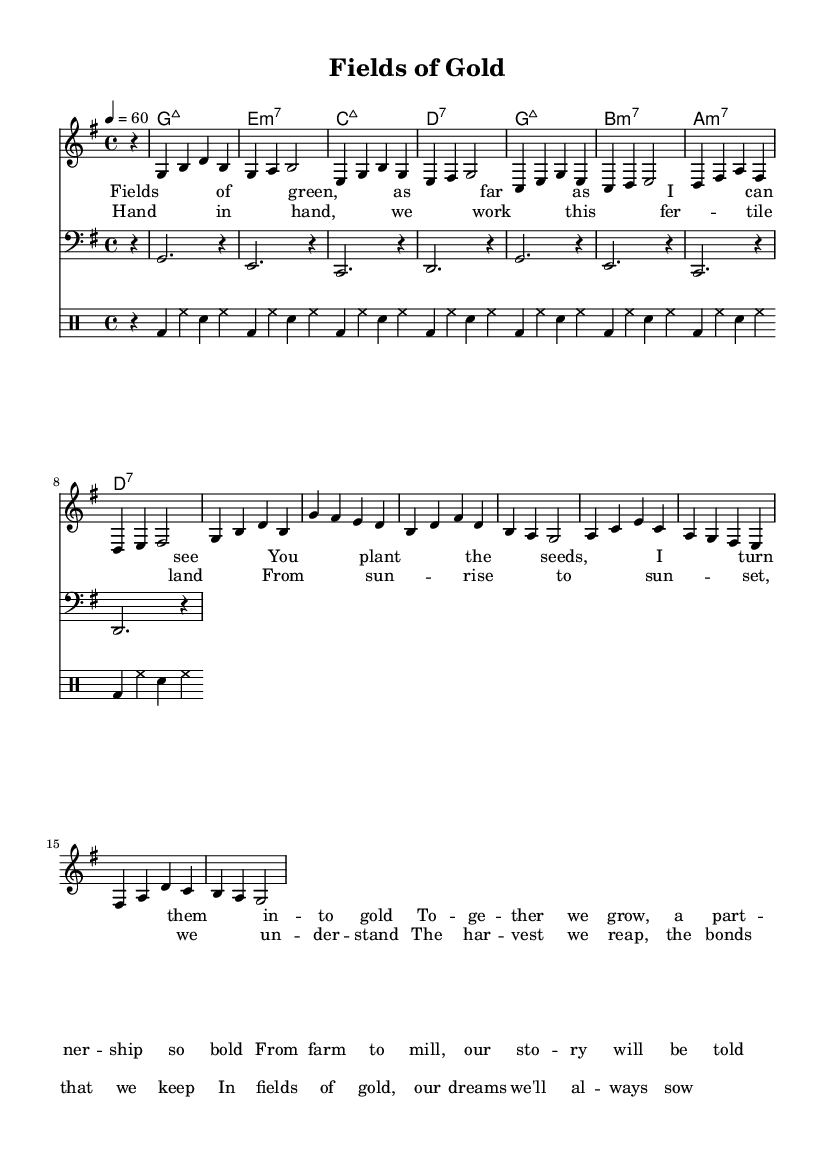What is the key signature of this music? The key signature is G major, which has one sharp (F#). This can be determined by looking at the key signature indicated at the beginning of the score.
Answer: G major What is the time signature of this piece? The time signature is 4/4, which is indicated at the beginning of the score. This means there are four beats per measure and the quarter note gets one beat.
Answer: 4/4 What is the tempo marking for the piece? The tempo marking is 60 beats per minute, given by the marking "4 = 60". This indicates the pace at which the piece should be played.
Answer: 60 What instruments are used in this score? The instruments are piano (melody and harmony), bass, and drums, which are indicated by the different staffs labeled in the score.
Answer: Piano, bass, drums How many measures are in the verse section? The verse section consists of 4 measures, as indicated by the melody notes and their groupings in the notation.
Answer: 4 What is the structure of the song based on the lyrics? The structure consists of verses and a chorus, where the verse presents the narrative and the chorus emphasizes the partnership theme, typical to rhythm and blues songs.
Answer: Verse, chorus Which chord follows the e minor seventh chord? The chord following e minor seventh is c major seventh, as indicated in the chord progression. The chords are listed sequentially, and this can be observed directly from the chord names section.
Answer: c major seventh 